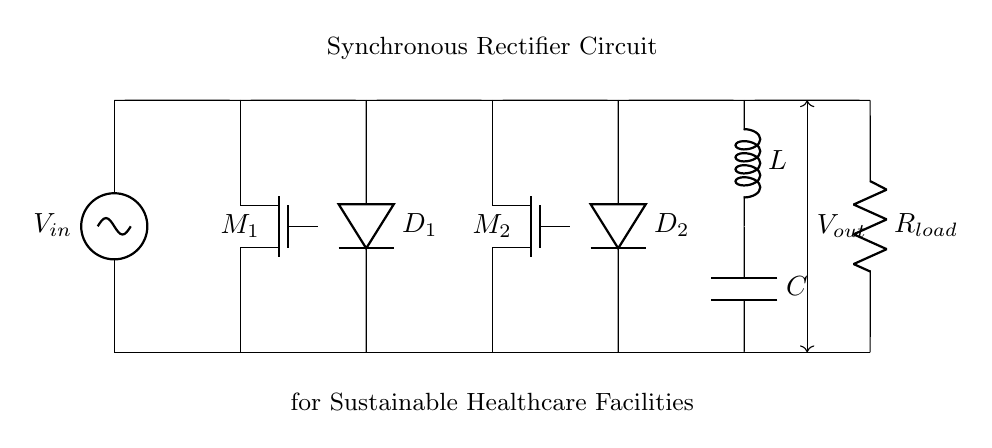What components are used in this circuit? The components in the circuit include two N-channel MOSFETs (M1 and M2), two diodes (D1 and D2), an inductor (L), a capacitor (C), and a load resistor (R_load). These components are essential for the operation of the synchronous rectifier circuit.
Answer: MOSFETs, diodes, inductor, capacitor, load resistor What is the purpose of the MOSFETs in this circuit? The MOSFETs (M1 and M2) serve as switches that replace traditional diodes, allowing for more efficient rectification by reducing the conduction losses during operation. This improves the overall efficiency of the power supply in the healthcare facility.
Answer: Switches for efficiency What is the function of the inductor in the circuit? The inductor (L) is used to store energy and smooth out the output current by resisting changes in current flow, which results in reduced ripples in the DC output. It plays a critical role in maintaining a stable output voltage.
Answer: Energy storage and smoothing How does this synchronous rectifier improve energy efficiency? The synchronous rectifier improves energy efficiency by utilizing MOSFETs instead of diodes, which have lower forward voltage drop leading to less power loss during rectification, hence increasing overall efficiency in the power supply for healthcare facilities.
Answer: Lower power loss What is the output of the circuit? The output voltage (V_out) is taken across the load resistor (R_load), representing the usable voltage supplied after rectification and filtering. This voltage is crucial for powering various electronic devices in a healthcare facility.
Answer: V_out across R_load 